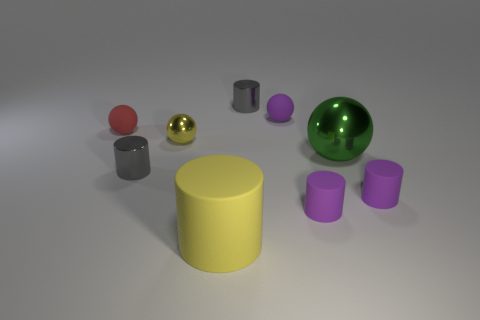Could you describe the arrangement of the objects in the image? Certainly. The objects are arranged in a seemingly random pattern with varying distances between them. At the forefront, a small red object catches the eye, hinting at a possible emphasis on it. The cylinders and spheres form a contrasting collection of shapes that offer the image both balance and a sense of deliberate placement. 